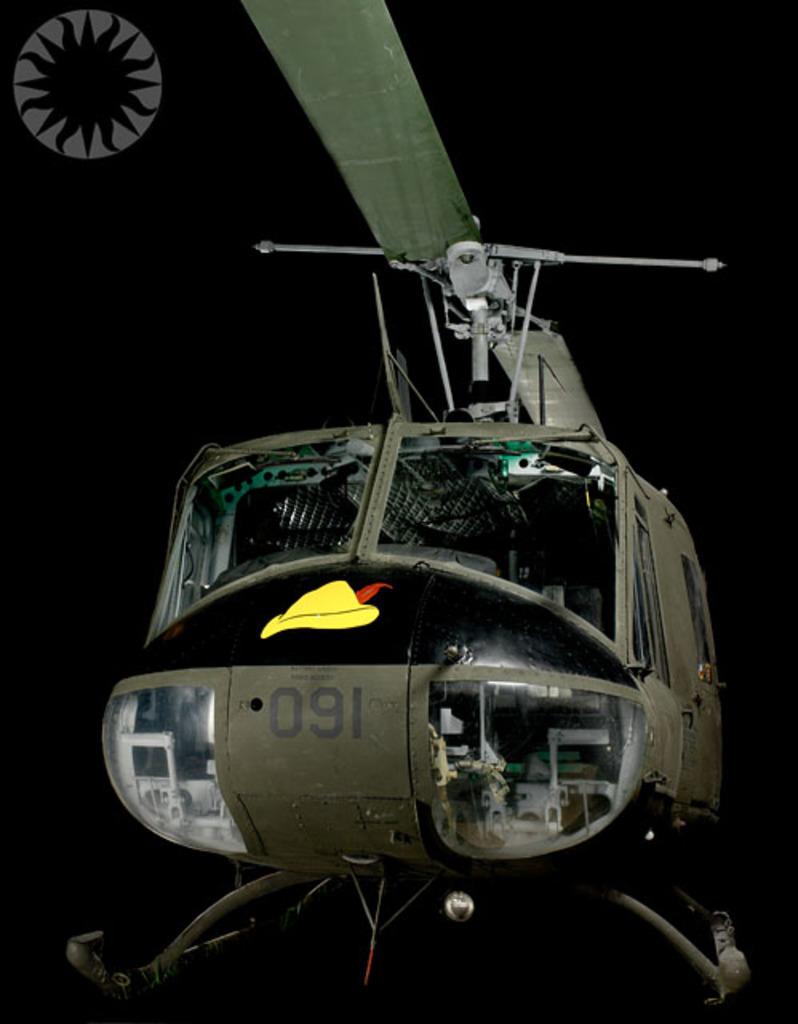The helicopter is number what?
Your answer should be very brief. 091. 